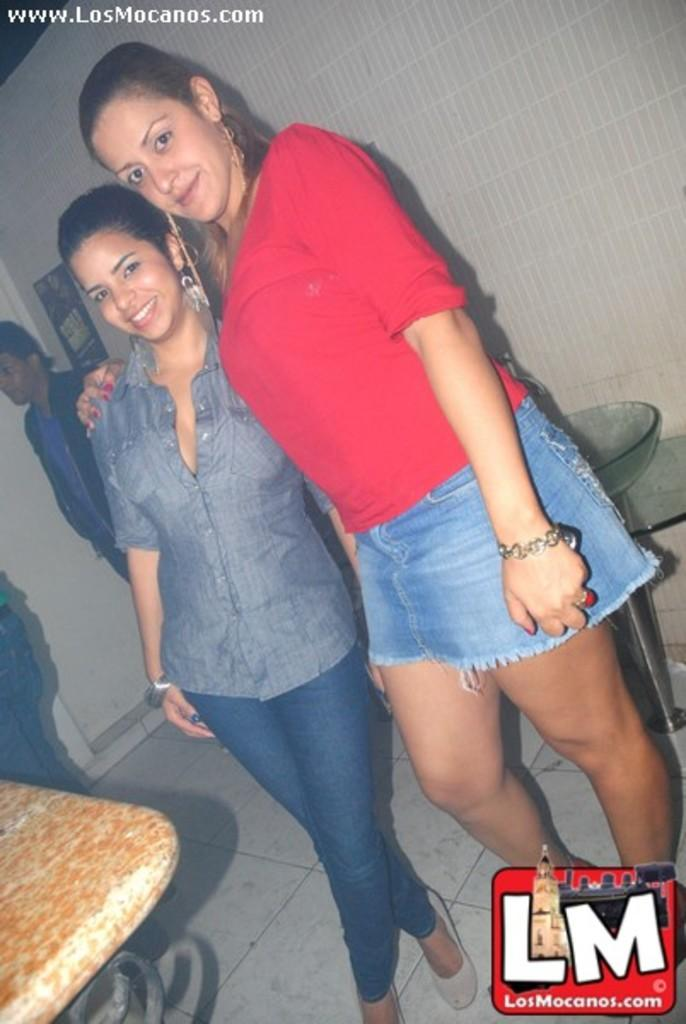What is the main subject of the image? There is a beautiful woman in the image. What is the woman doing in the image? The woman is standing. What is the woman wearing in the image? The woman is wearing a red color top and blue color shorts. Are there any other people in the image? Yes, there is another girl in the image. What is the girl doing in the image? The girl is standing and smiling. What type of lettuce is being used as a hat by the woman in the image? There is no lettuce present in the image, and the woman is not wearing a hat. How much debt is the girl in the image currently facing? There is no information about the girl's debt in the image. 